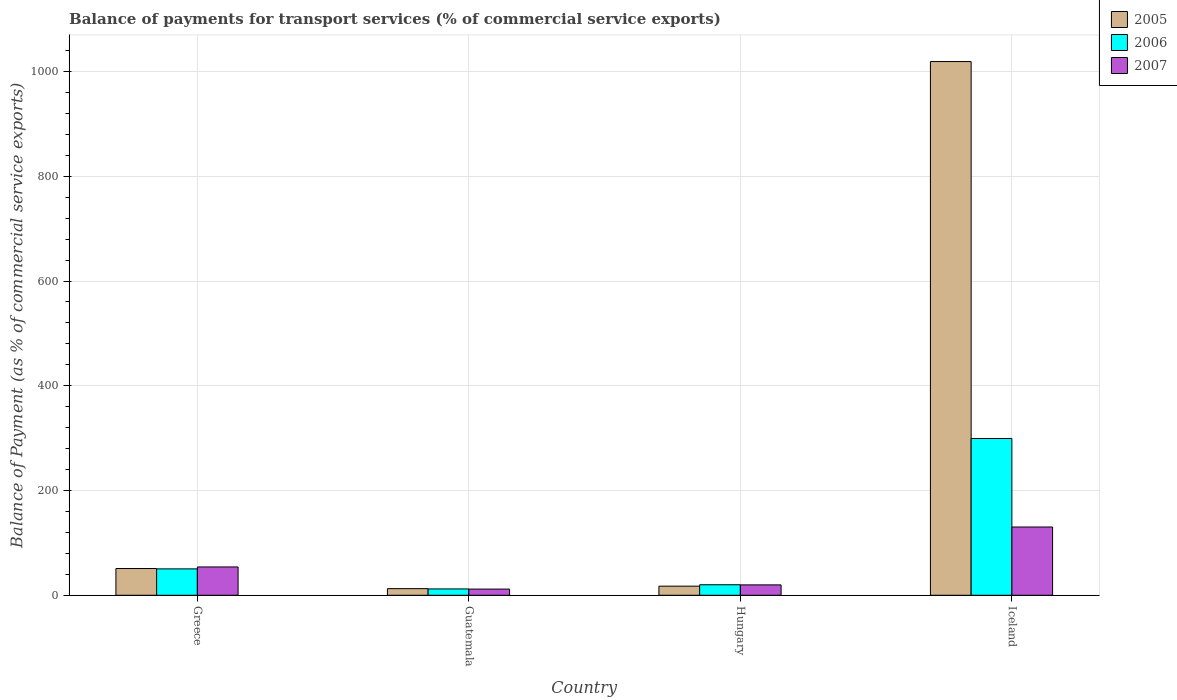How many different coloured bars are there?
Provide a succinct answer. 3. How many groups of bars are there?
Provide a short and direct response. 4. Are the number of bars on each tick of the X-axis equal?
Provide a succinct answer. Yes. How many bars are there on the 2nd tick from the right?
Offer a terse response. 3. What is the label of the 4th group of bars from the left?
Provide a short and direct response. Iceland. In how many cases, is the number of bars for a given country not equal to the number of legend labels?
Make the answer very short. 0. What is the balance of payments for transport services in 2006 in Hungary?
Your answer should be very brief. 20.09. Across all countries, what is the maximum balance of payments for transport services in 2006?
Provide a short and direct response. 299.28. Across all countries, what is the minimum balance of payments for transport services in 2005?
Give a very brief answer. 12.65. In which country was the balance of payments for transport services in 2005 maximum?
Make the answer very short. Iceland. In which country was the balance of payments for transport services in 2007 minimum?
Your response must be concise. Guatemala. What is the total balance of payments for transport services in 2007 in the graph?
Make the answer very short. 216.06. What is the difference between the balance of payments for transport services in 2005 in Guatemala and that in Hungary?
Your answer should be compact. -4.75. What is the difference between the balance of payments for transport services in 2006 in Iceland and the balance of payments for transport services in 2005 in Guatemala?
Offer a terse response. 286.63. What is the average balance of payments for transport services in 2006 per country?
Provide a succinct answer. 95.46. What is the difference between the balance of payments for transport services of/in 2006 and balance of payments for transport services of/in 2007 in Greece?
Your response must be concise. -3.69. What is the ratio of the balance of payments for transport services in 2006 in Hungary to that in Iceland?
Your answer should be compact. 0.07. What is the difference between the highest and the second highest balance of payments for transport services in 2007?
Ensure brevity in your answer.  110.47. What is the difference between the highest and the lowest balance of payments for transport services in 2007?
Your answer should be very brief. 118.5. What does the 2nd bar from the right in Greece represents?
Provide a succinct answer. 2006. How many countries are there in the graph?
Keep it short and to the point. 4. What is the difference between two consecutive major ticks on the Y-axis?
Offer a very short reply. 200. Are the values on the major ticks of Y-axis written in scientific E-notation?
Your answer should be very brief. No. Does the graph contain any zero values?
Ensure brevity in your answer.  No. Does the graph contain grids?
Your answer should be very brief. Yes. Where does the legend appear in the graph?
Give a very brief answer. Top right. What is the title of the graph?
Make the answer very short. Balance of payments for transport services (% of commercial service exports). What is the label or title of the Y-axis?
Ensure brevity in your answer.  Balance of Payment (as % of commercial service exports). What is the Balance of Payment (as % of commercial service exports) of 2005 in Greece?
Give a very brief answer. 51.08. What is the Balance of Payment (as % of commercial service exports) of 2006 in Greece?
Provide a succinct answer. 50.38. What is the Balance of Payment (as % of commercial service exports) in 2007 in Greece?
Offer a terse response. 54.07. What is the Balance of Payment (as % of commercial service exports) of 2005 in Guatemala?
Give a very brief answer. 12.65. What is the Balance of Payment (as % of commercial service exports) of 2006 in Guatemala?
Your answer should be compact. 12.1. What is the Balance of Payment (as % of commercial service exports) of 2007 in Guatemala?
Ensure brevity in your answer.  11.82. What is the Balance of Payment (as % of commercial service exports) of 2005 in Hungary?
Your answer should be compact. 17.4. What is the Balance of Payment (as % of commercial service exports) in 2006 in Hungary?
Ensure brevity in your answer.  20.09. What is the Balance of Payment (as % of commercial service exports) of 2007 in Hungary?
Offer a very short reply. 19.85. What is the Balance of Payment (as % of commercial service exports) of 2005 in Iceland?
Ensure brevity in your answer.  1018.95. What is the Balance of Payment (as % of commercial service exports) of 2006 in Iceland?
Ensure brevity in your answer.  299.28. What is the Balance of Payment (as % of commercial service exports) of 2007 in Iceland?
Keep it short and to the point. 130.32. Across all countries, what is the maximum Balance of Payment (as % of commercial service exports) of 2005?
Give a very brief answer. 1018.95. Across all countries, what is the maximum Balance of Payment (as % of commercial service exports) in 2006?
Make the answer very short. 299.28. Across all countries, what is the maximum Balance of Payment (as % of commercial service exports) of 2007?
Offer a terse response. 130.32. Across all countries, what is the minimum Balance of Payment (as % of commercial service exports) of 2005?
Keep it short and to the point. 12.65. Across all countries, what is the minimum Balance of Payment (as % of commercial service exports) of 2006?
Make the answer very short. 12.1. Across all countries, what is the minimum Balance of Payment (as % of commercial service exports) of 2007?
Your response must be concise. 11.82. What is the total Balance of Payment (as % of commercial service exports) of 2005 in the graph?
Your answer should be very brief. 1100.08. What is the total Balance of Payment (as % of commercial service exports) of 2006 in the graph?
Your response must be concise. 381.85. What is the total Balance of Payment (as % of commercial service exports) in 2007 in the graph?
Ensure brevity in your answer.  216.06. What is the difference between the Balance of Payment (as % of commercial service exports) in 2005 in Greece and that in Guatemala?
Your answer should be very brief. 38.43. What is the difference between the Balance of Payment (as % of commercial service exports) in 2006 in Greece and that in Guatemala?
Provide a succinct answer. 38.28. What is the difference between the Balance of Payment (as % of commercial service exports) in 2007 in Greece and that in Guatemala?
Your answer should be compact. 42.25. What is the difference between the Balance of Payment (as % of commercial service exports) in 2005 in Greece and that in Hungary?
Your answer should be very brief. 33.67. What is the difference between the Balance of Payment (as % of commercial service exports) of 2006 in Greece and that in Hungary?
Your answer should be compact. 30.29. What is the difference between the Balance of Payment (as % of commercial service exports) in 2007 in Greece and that in Hungary?
Keep it short and to the point. 34.22. What is the difference between the Balance of Payment (as % of commercial service exports) of 2005 in Greece and that in Iceland?
Your response must be concise. -967.88. What is the difference between the Balance of Payment (as % of commercial service exports) of 2006 in Greece and that in Iceland?
Keep it short and to the point. -248.89. What is the difference between the Balance of Payment (as % of commercial service exports) in 2007 in Greece and that in Iceland?
Provide a succinct answer. -76.25. What is the difference between the Balance of Payment (as % of commercial service exports) in 2005 in Guatemala and that in Hungary?
Offer a very short reply. -4.75. What is the difference between the Balance of Payment (as % of commercial service exports) of 2006 in Guatemala and that in Hungary?
Provide a short and direct response. -7.99. What is the difference between the Balance of Payment (as % of commercial service exports) of 2007 in Guatemala and that in Hungary?
Offer a very short reply. -8.03. What is the difference between the Balance of Payment (as % of commercial service exports) in 2005 in Guatemala and that in Iceland?
Ensure brevity in your answer.  -1006.3. What is the difference between the Balance of Payment (as % of commercial service exports) of 2006 in Guatemala and that in Iceland?
Ensure brevity in your answer.  -287.17. What is the difference between the Balance of Payment (as % of commercial service exports) of 2007 in Guatemala and that in Iceland?
Your answer should be compact. -118.5. What is the difference between the Balance of Payment (as % of commercial service exports) in 2005 in Hungary and that in Iceland?
Ensure brevity in your answer.  -1001.55. What is the difference between the Balance of Payment (as % of commercial service exports) in 2006 in Hungary and that in Iceland?
Keep it short and to the point. -279.19. What is the difference between the Balance of Payment (as % of commercial service exports) of 2007 in Hungary and that in Iceland?
Keep it short and to the point. -110.47. What is the difference between the Balance of Payment (as % of commercial service exports) in 2005 in Greece and the Balance of Payment (as % of commercial service exports) in 2006 in Guatemala?
Give a very brief answer. 38.97. What is the difference between the Balance of Payment (as % of commercial service exports) in 2005 in Greece and the Balance of Payment (as % of commercial service exports) in 2007 in Guatemala?
Your response must be concise. 39.26. What is the difference between the Balance of Payment (as % of commercial service exports) of 2006 in Greece and the Balance of Payment (as % of commercial service exports) of 2007 in Guatemala?
Make the answer very short. 38.56. What is the difference between the Balance of Payment (as % of commercial service exports) of 2005 in Greece and the Balance of Payment (as % of commercial service exports) of 2006 in Hungary?
Give a very brief answer. 30.99. What is the difference between the Balance of Payment (as % of commercial service exports) in 2005 in Greece and the Balance of Payment (as % of commercial service exports) in 2007 in Hungary?
Keep it short and to the point. 31.23. What is the difference between the Balance of Payment (as % of commercial service exports) of 2006 in Greece and the Balance of Payment (as % of commercial service exports) of 2007 in Hungary?
Ensure brevity in your answer.  30.53. What is the difference between the Balance of Payment (as % of commercial service exports) in 2005 in Greece and the Balance of Payment (as % of commercial service exports) in 2006 in Iceland?
Provide a short and direct response. -248.2. What is the difference between the Balance of Payment (as % of commercial service exports) of 2005 in Greece and the Balance of Payment (as % of commercial service exports) of 2007 in Iceland?
Ensure brevity in your answer.  -79.25. What is the difference between the Balance of Payment (as % of commercial service exports) in 2006 in Greece and the Balance of Payment (as % of commercial service exports) in 2007 in Iceland?
Provide a succinct answer. -79.94. What is the difference between the Balance of Payment (as % of commercial service exports) in 2005 in Guatemala and the Balance of Payment (as % of commercial service exports) in 2006 in Hungary?
Provide a short and direct response. -7.44. What is the difference between the Balance of Payment (as % of commercial service exports) of 2005 in Guatemala and the Balance of Payment (as % of commercial service exports) of 2007 in Hungary?
Provide a short and direct response. -7.2. What is the difference between the Balance of Payment (as % of commercial service exports) of 2006 in Guatemala and the Balance of Payment (as % of commercial service exports) of 2007 in Hungary?
Keep it short and to the point. -7.74. What is the difference between the Balance of Payment (as % of commercial service exports) in 2005 in Guatemala and the Balance of Payment (as % of commercial service exports) in 2006 in Iceland?
Your response must be concise. -286.63. What is the difference between the Balance of Payment (as % of commercial service exports) of 2005 in Guatemala and the Balance of Payment (as % of commercial service exports) of 2007 in Iceland?
Provide a short and direct response. -117.67. What is the difference between the Balance of Payment (as % of commercial service exports) in 2006 in Guatemala and the Balance of Payment (as % of commercial service exports) in 2007 in Iceland?
Keep it short and to the point. -118.22. What is the difference between the Balance of Payment (as % of commercial service exports) in 2005 in Hungary and the Balance of Payment (as % of commercial service exports) in 2006 in Iceland?
Offer a terse response. -281.87. What is the difference between the Balance of Payment (as % of commercial service exports) in 2005 in Hungary and the Balance of Payment (as % of commercial service exports) in 2007 in Iceland?
Keep it short and to the point. -112.92. What is the difference between the Balance of Payment (as % of commercial service exports) of 2006 in Hungary and the Balance of Payment (as % of commercial service exports) of 2007 in Iceland?
Make the answer very short. -110.23. What is the average Balance of Payment (as % of commercial service exports) of 2005 per country?
Provide a succinct answer. 275.02. What is the average Balance of Payment (as % of commercial service exports) in 2006 per country?
Offer a terse response. 95.46. What is the average Balance of Payment (as % of commercial service exports) in 2007 per country?
Offer a very short reply. 54.02. What is the difference between the Balance of Payment (as % of commercial service exports) in 2005 and Balance of Payment (as % of commercial service exports) in 2006 in Greece?
Provide a short and direct response. 0.7. What is the difference between the Balance of Payment (as % of commercial service exports) in 2005 and Balance of Payment (as % of commercial service exports) in 2007 in Greece?
Provide a short and direct response. -2.99. What is the difference between the Balance of Payment (as % of commercial service exports) in 2006 and Balance of Payment (as % of commercial service exports) in 2007 in Greece?
Offer a terse response. -3.69. What is the difference between the Balance of Payment (as % of commercial service exports) in 2005 and Balance of Payment (as % of commercial service exports) in 2006 in Guatemala?
Ensure brevity in your answer.  0.54. What is the difference between the Balance of Payment (as % of commercial service exports) in 2005 and Balance of Payment (as % of commercial service exports) in 2007 in Guatemala?
Keep it short and to the point. 0.83. What is the difference between the Balance of Payment (as % of commercial service exports) in 2006 and Balance of Payment (as % of commercial service exports) in 2007 in Guatemala?
Provide a short and direct response. 0.28. What is the difference between the Balance of Payment (as % of commercial service exports) of 2005 and Balance of Payment (as % of commercial service exports) of 2006 in Hungary?
Offer a very short reply. -2.69. What is the difference between the Balance of Payment (as % of commercial service exports) of 2005 and Balance of Payment (as % of commercial service exports) of 2007 in Hungary?
Provide a succinct answer. -2.45. What is the difference between the Balance of Payment (as % of commercial service exports) of 2006 and Balance of Payment (as % of commercial service exports) of 2007 in Hungary?
Provide a short and direct response. 0.24. What is the difference between the Balance of Payment (as % of commercial service exports) in 2005 and Balance of Payment (as % of commercial service exports) in 2006 in Iceland?
Provide a succinct answer. 719.68. What is the difference between the Balance of Payment (as % of commercial service exports) of 2005 and Balance of Payment (as % of commercial service exports) of 2007 in Iceland?
Your answer should be compact. 888.63. What is the difference between the Balance of Payment (as % of commercial service exports) of 2006 and Balance of Payment (as % of commercial service exports) of 2007 in Iceland?
Keep it short and to the point. 168.95. What is the ratio of the Balance of Payment (as % of commercial service exports) of 2005 in Greece to that in Guatemala?
Offer a very short reply. 4.04. What is the ratio of the Balance of Payment (as % of commercial service exports) in 2006 in Greece to that in Guatemala?
Your response must be concise. 4.16. What is the ratio of the Balance of Payment (as % of commercial service exports) of 2007 in Greece to that in Guatemala?
Keep it short and to the point. 4.57. What is the ratio of the Balance of Payment (as % of commercial service exports) of 2005 in Greece to that in Hungary?
Keep it short and to the point. 2.94. What is the ratio of the Balance of Payment (as % of commercial service exports) of 2006 in Greece to that in Hungary?
Provide a succinct answer. 2.51. What is the ratio of the Balance of Payment (as % of commercial service exports) of 2007 in Greece to that in Hungary?
Offer a terse response. 2.72. What is the ratio of the Balance of Payment (as % of commercial service exports) of 2005 in Greece to that in Iceland?
Keep it short and to the point. 0.05. What is the ratio of the Balance of Payment (as % of commercial service exports) in 2006 in Greece to that in Iceland?
Provide a short and direct response. 0.17. What is the ratio of the Balance of Payment (as % of commercial service exports) of 2007 in Greece to that in Iceland?
Make the answer very short. 0.41. What is the ratio of the Balance of Payment (as % of commercial service exports) of 2005 in Guatemala to that in Hungary?
Give a very brief answer. 0.73. What is the ratio of the Balance of Payment (as % of commercial service exports) in 2006 in Guatemala to that in Hungary?
Your response must be concise. 0.6. What is the ratio of the Balance of Payment (as % of commercial service exports) of 2007 in Guatemala to that in Hungary?
Your answer should be compact. 0.6. What is the ratio of the Balance of Payment (as % of commercial service exports) in 2005 in Guatemala to that in Iceland?
Provide a succinct answer. 0.01. What is the ratio of the Balance of Payment (as % of commercial service exports) in 2006 in Guatemala to that in Iceland?
Provide a short and direct response. 0.04. What is the ratio of the Balance of Payment (as % of commercial service exports) in 2007 in Guatemala to that in Iceland?
Your response must be concise. 0.09. What is the ratio of the Balance of Payment (as % of commercial service exports) in 2005 in Hungary to that in Iceland?
Your answer should be compact. 0.02. What is the ratio of the Balance of Payment (as % of commercial service exports) of 2006 in Hungary to that in Iceland?
Provide a short and direct response. 0.07. What is the ratio of the Balance of Payment (as % of commercial service exports) of 2007 in Hungary to that in Iceland?
Offer a very short reply. 0.15. What is the difference between the highest and the second highest Balance of Payment (as % of commercial service exports) in 2005?
Your answer should be very brief. 967.88. What is the difference between the highest and the second highest Balance of Payment (as % of commercial service exports) in 2006?
Ensure brevity in your answer.  248.89. What is the difference between the highest and the second highest Balance of Payment (as % of commercial service exports) of 2007?
Your response must be concise. 76.25. What is the difference between the highest and the lowest Balance of Payment (as % of commercial service exports) in 2005?
Make the answer very short. 1006.3. What is the difference between the highest and the lowest Balance of Payment (as % of commercial service exports) in 2006?
Your answer should be compact. 287.17. What is the difference between the highest and the lowest Balance of Payment (as % of commercial service exports) in 2007?
Offer a terse response. 118.5. 